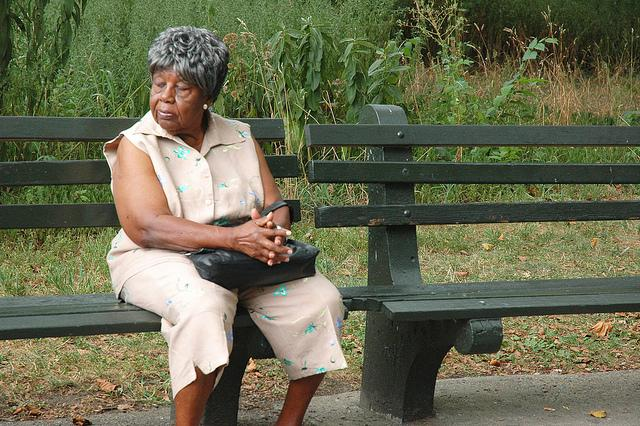What activity is the old lady engaging in? sitting 